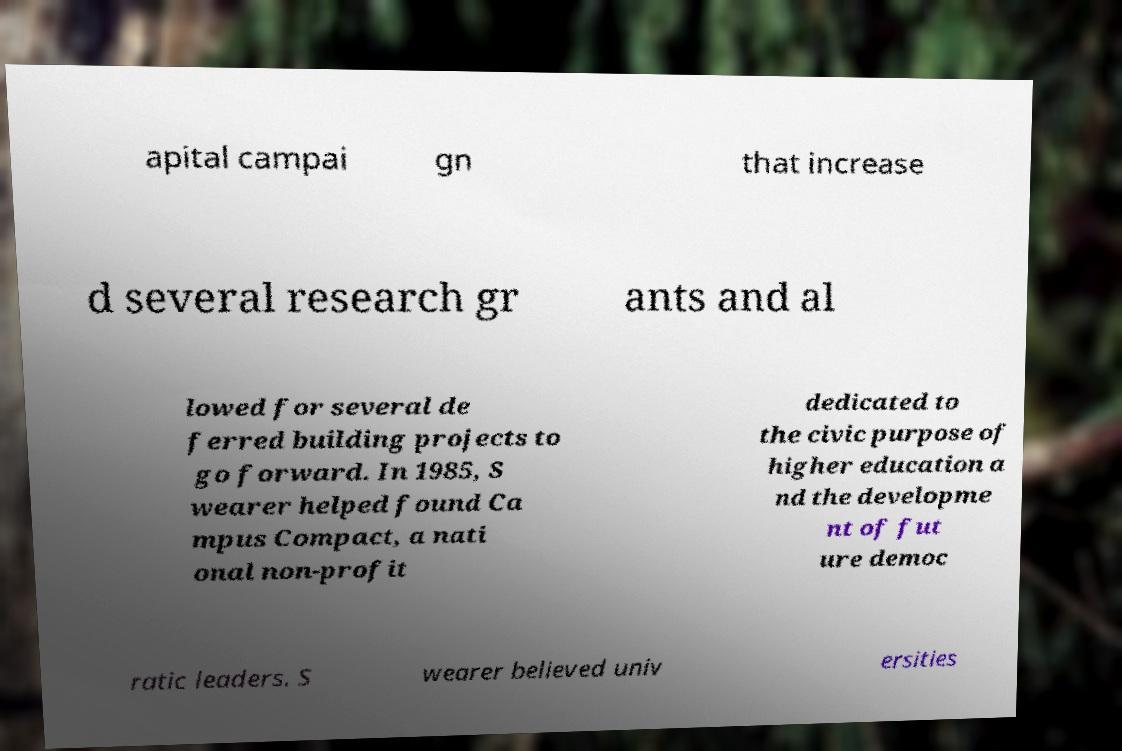For documentation purposes, I need the text within this image transcribed. Could you provide that? apital campai gn that increase d several research gr ants and al lowed for several de ferred building projects to go forward. In 1985, S wearer helped found Ca mpus Compact, a nati onal non-profit dedicated to the civic purpose of higher education a nd the developme nt of fut ure democ ratic leaders. S wearer believed univ ersities 